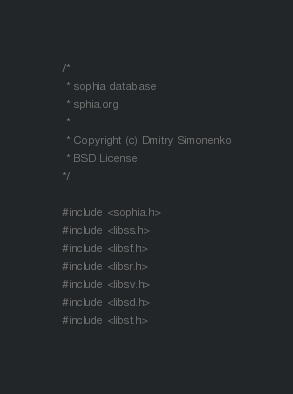<code> <loc_0><loc_0><loc_500><loc_500><_C_>
/*
 * sophia database
 * sphia.org
 *
 * Copyright (c) Dmitry Simonenko
 * BSD License
*/

#include <sophia.h>
#include <libss.h>
#include <libsf.h>
#include <libsr.h>
#include <libsv.h>
#include <libsd.h>
#include <libst.h>
</code> 